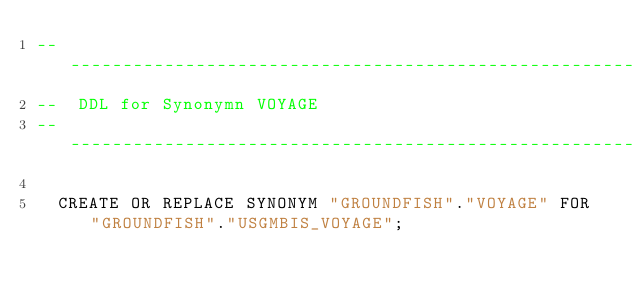Convert code to text. <code><loc_0><loc_0><loc_500><loc_500><_SQL_>--------------------------------------------------------
--  DDL for Synonymn VOYAGE
--------------------------------------------------------

  CREATE OR REPLACE SYNONYM "GROUNDFISH"."VOYAGE" FOR "GROUNDFISH"."USGMBIS_VOYAGE";
</code> 